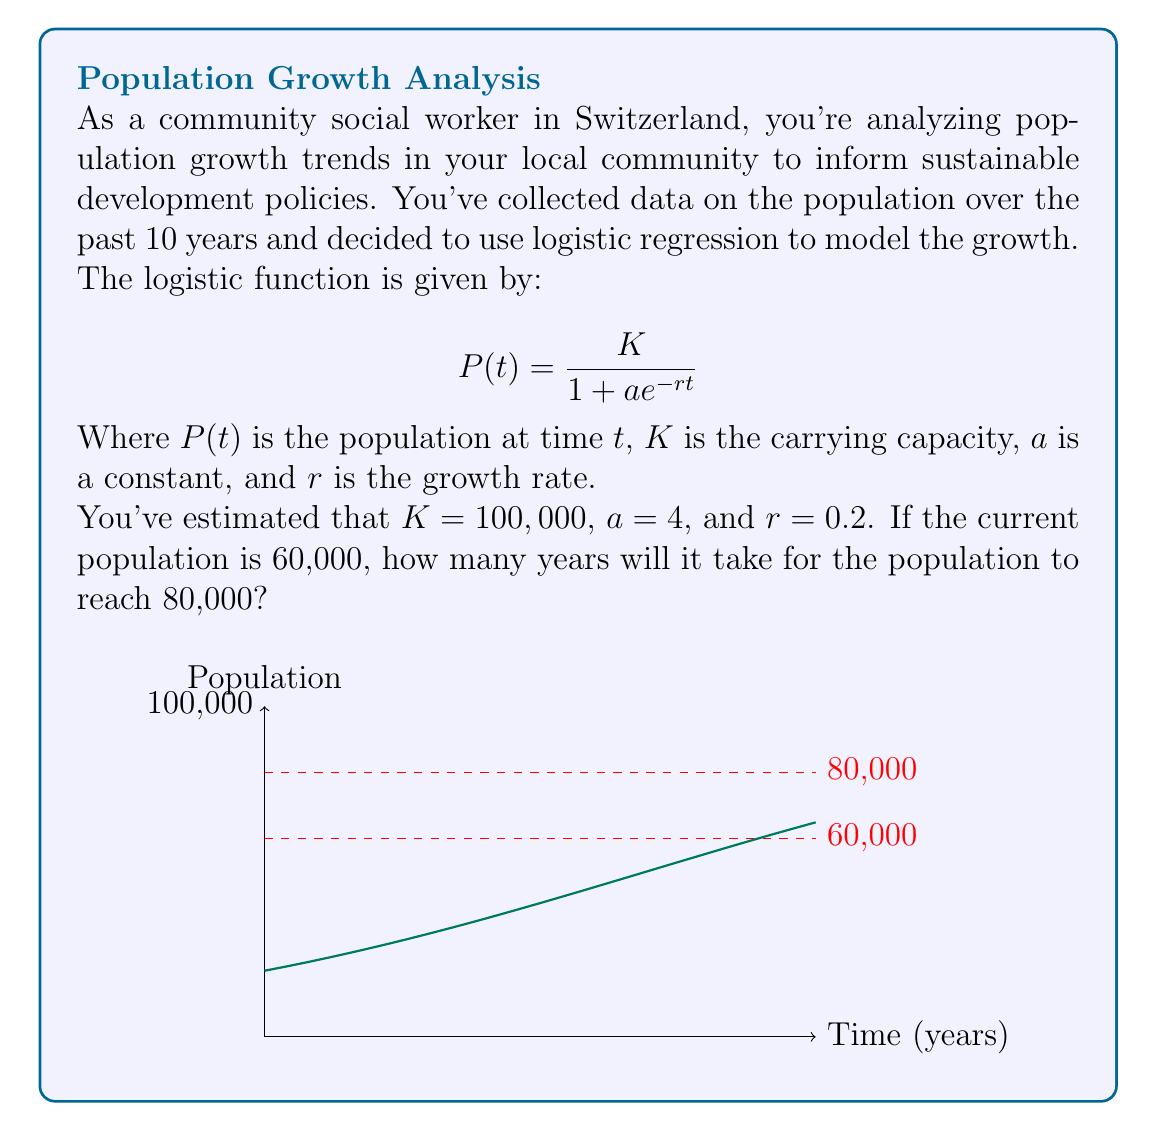Show me your answer to this math problem. Let's approach this step-by-step:

1) We start with the logistic function:

   $$P(t) = \frac{K}{1 + ae^{-rt}}$$

2) We know that $K = 100,000$, $a = 4$, and $r = 0.2$. We want to find $t$ when $P(t) = 80,000$. Let's substitute these values:

   $$80,000 = \frac{100,000}{1 + 4e^{-0.2t}}$$

3) Now, let's solve this equation for $t$:

   $$0.8 = \frac{1}{1 + 4e^{-0.2t}}$$

4) Take the reciprocal of both sides:

   $$1.25 = 1 + 4e^{-0.2t}$$

5) Subtract 1 from both sides:

   $$0.25 = 4e^{-0.2t}$$

6) Divide both sides by 4:

   $$0.0625 = e^{-0.2t}$$

7) Take the natural log of both sides:

   $$\ln(0.0625) = -0.2t$$

8) Solve for $t$:

   $$t = \frac{-\ln(0.0625)}{0.2} \approx 13.86$$

Therefore, it will take approximately 13.86 years for the population to reach 80,000.
Answer: 13.86 years 